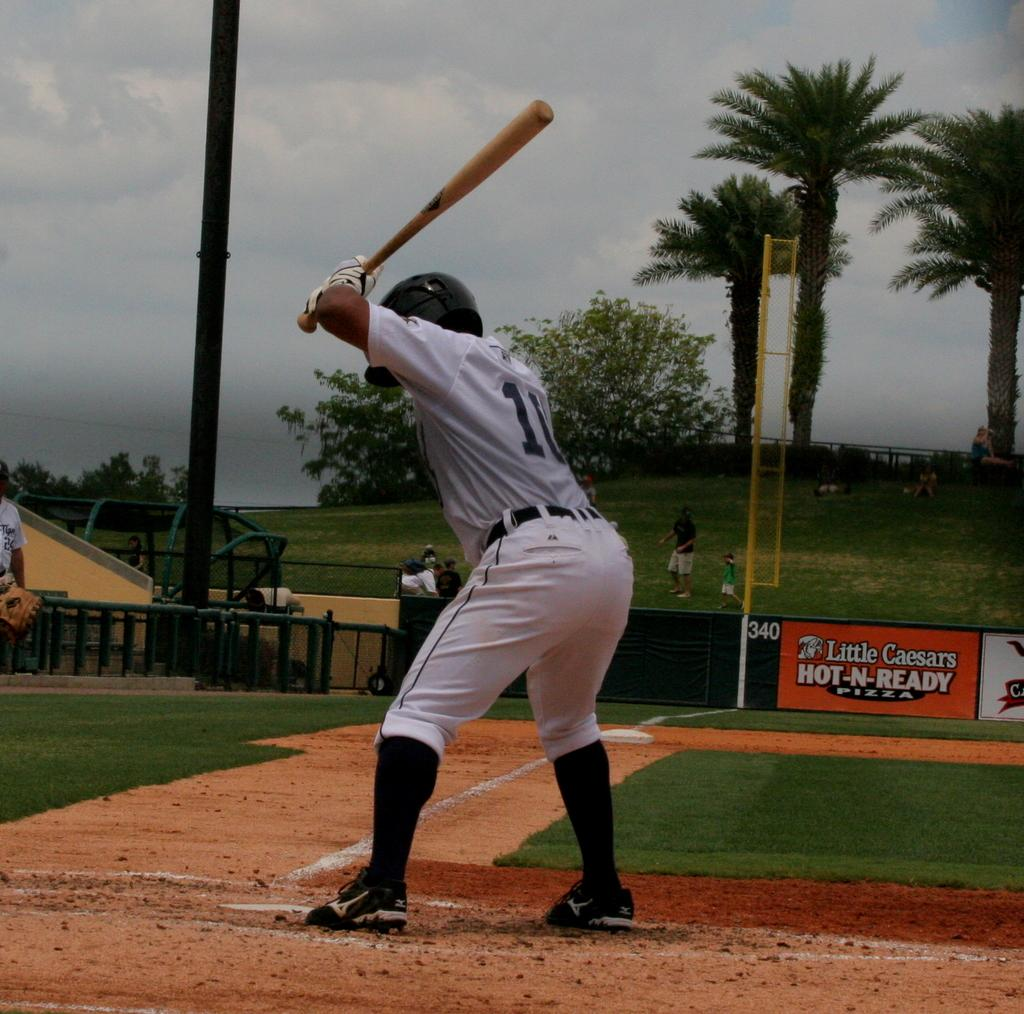<image>
Share a concise interpretation of the image provided. A person is getting ready to hit a baseball in a field that advertises for Little Caesars. 